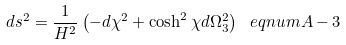Convert formula to latex. <formula><loc_0><loc_0><loc_500><loc_500>d s ^ { 2 } = \frac { 1 } { H ^ { 2 } } \left ( - d \chi ^ { 2 } + \cosh ^ { 2 } \chi d \Omega _ { 3 } ^ { 2 } \right ) \ e q n u m { A - 3 }</formula> 